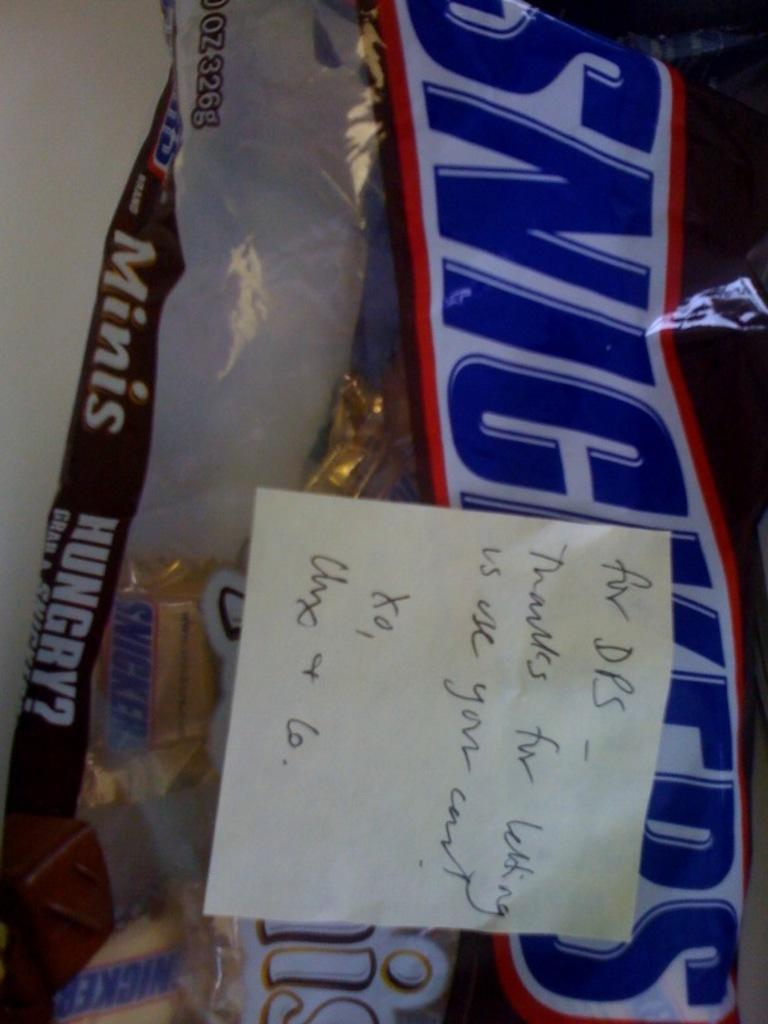What type of product is shown in the image? There is a Snickers packet in the image. What is covering the Snickers packet? There is a paper pasted on the Snickers packet. What can be seen inside the packet? There are chocolates visible inside the packet. What information is provided on the paper pasted on the packet? There is text on the paper pasted on the packet. What type of fruit is being used to scoop out the chocolates from the packet? There is no fruit present in the image, and the chocolates are not being scooped out with any object. 